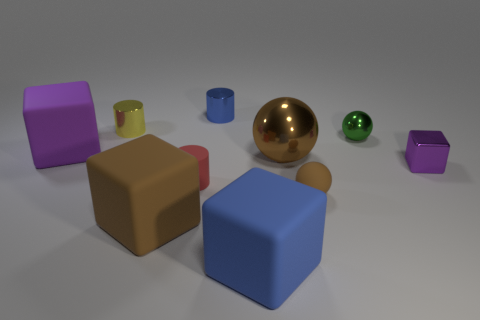Subtract all blocks. How many objects are left? 6 Add 7 matte cylinders. How many matte cylinders exist? 8 Subtract 0 gray balls. How many objects are left? 10 Subtract all big rubber blocks. Subtract all yellow shiny cylinders. How many objects are left? 6 Add 8 tiny brown spheres. How many tiny brown spheres are left? 9 